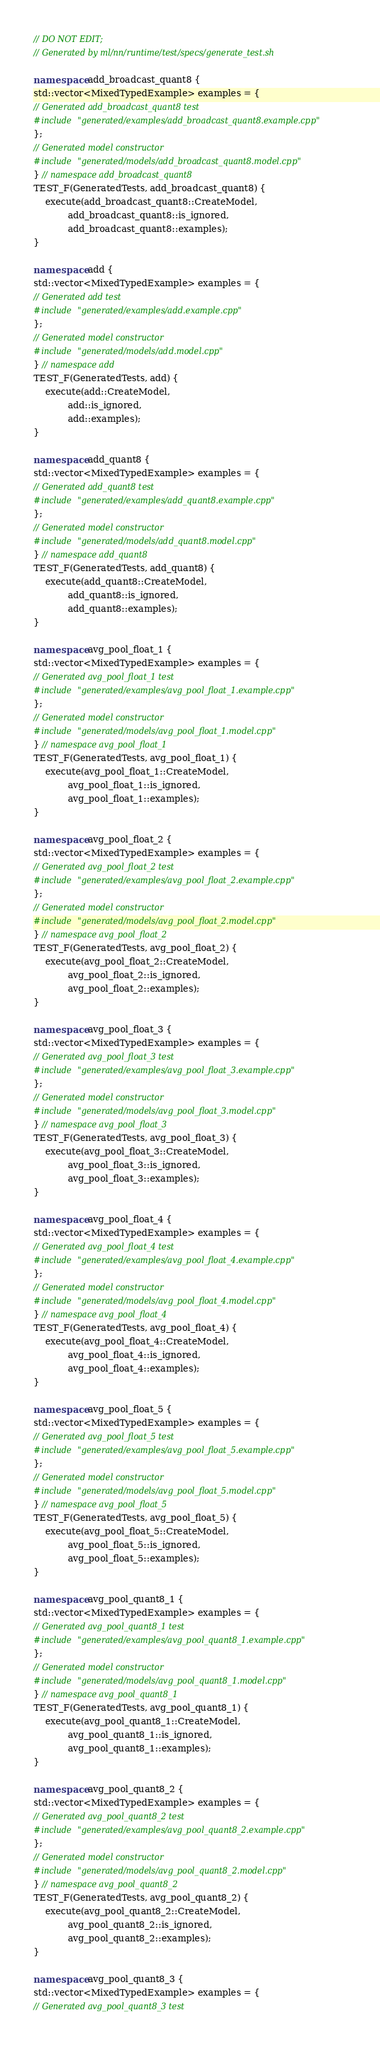<code> <loc_0><loc_0><loc_500><loc_500><_C++_>// DO NOT EDIT;
// Generated by ml/nn/runtime/test/specs/generate_test.sh

namespace add_broadcast_quant8 {
std::vector<MixedTypedExample> examples = {
// Generated add_broadcast_quant8 test
#include "generated/examples/add_broadcast_quant8.example.cpp"
};
// Generated model constructor
#include "generated/models/add_broadcast_quant8.model.cpp"
} // namespace add_broadcast_quant8
TEST_F(GeneratedTests, add_broadcast_quant8) {
    execute(add_broadcast_quant8::CreateModel,
            add_broadcast_quant8::is_ignored,
            add_broadcast_quant8::examples);
}

namespace add {
std::vector<MixedTypedExample> examples = {
// Generated add test
#include "generated/examples/add.example.cpp"
};
// Generated model constructor
#include "generated/models/add.model.cpp"
} // namespace add
TEST_F(GeneratedTests, add) {
    execute(add::CreateModel,
            add::is_ignored,
            add::examples);
}

namespace add_quant8 {
std::vector<MixedTypedExample> examples = {
// Generated add_quant8 test
#include "generated/examples/add_quant8.example.cpp"
};
// Generated model constructor
#include "generated/models/add_quant8.model.cpp"
} // namespace add_quant8
TEST_F(GeneratedTests, add_quant8) {
    execute(add_quant8::CreateModel,
            add_quant8::is_ignored,
            add_quant8::examples);
}

namespace avg_pool_float_1 {
std::vector<MixedTypedExample> examples = {
// Generated avg_pool_float_1 test
#include "generated/examples/avg_pool_float_1.example.cpp"
};
// Generated model constructor
#include "generated/models/avg_pool_float_1.model.cpp"
} // namespace avg_pool_float_1
TEST_F(GeneratedTests, avg_pool_float_1) {
    execute(avg_pool_float_1::CreateModel,
            avg_pool_float_1::is_ignored,
            avg_pool_float_1::examples);
}

namespace avg_pool_float_2 {
std::vector<MixedTypedExample> examples = {
// Generated avg_pool_float_2 test
#include "generated/examples/avg_pool_float_2.example.cpp"
};
// Generated model constructor
#include "generated/models/avg_pool_float_2.model.cpp"
} // namespace avg_pool_float_2
TEST_F(GeneratedTests, avg_pool_float_2) {
    execute(avg_pool_float_2::CreateModel,
            avg_pool_float_2::is_ignored,
            avg_pool_float_2::examples);
}

namespace avg_pool_float_3 {
std::vector<MixedTypedExample> examples = {
// Generated avg_pool_float_3 test
#include "generated/examples/avg_pool_float_3.example.cpp"
};
// Generated model constructor
#include "generated/models/avg_pool_float_3.model.cpp"
} // namespace avg_pool_float_3
TEST_F(GeneratedTests, avg_pool_float_3) {
    execute(avg_pool_float_3::CreateModel,
            avg_pool_float_3::is_ignored,
            avg_pool_float_3::examples);
}

namespace avg_pool_float_4 {
std::vector<MixedTypedExample> examples = {
// Generated avg_pool_float_4 test
#include "generated/examples/avg_pool_float_4.example.cpp"
};
// Generated model constructor
#include "generated/models/avg_pool_float_4.model.cpp"
} // namespace avg_pool_float_4
TEST_F(GeneratedTests, avg_pool_float_4) {
    execute(avg_pool_float_4::CreateModel,
            avg_pool_float_4::is_ignored,
            avg_pool_float_4::examples);
}

namespace avg_pool_float_5 {
std::vector<MixedTypedExample> examples = {
// Generated avg_pool_float_5 test
#include "generated/examples/avg_pool_float_5.example.cpp"
};
// Generated model constructor
#include "generated/models/avg_pool_float_5.model.cpp"
} // namespace avg_pool_float_5
TEST_F(GeneratedTests, avg_pool_float_5) {
    execute(avg_pool_float_5::CreateModel,
            avg_pool_float_5::is_ignored,
            avg_pool_float_5::examples);
}

namespace avg_pool_quant8_1 {
std::vector<MixedTypedExample> examples = {
// Generated avg_pool_quant8_1 test
#include "generated/examples/avg_pool_quant8_1.example.cpp"
};
// Generated model constructor
#include "generated/models/avg_pool_quant8_1.model.cpp"
} // namespace avg_pool_quant8_1
TEST_F(GeneratedTests, avg_pool_quant8_1) {
    execute(avg_pool_quant8_1::CreateModel,
            avg_pool_quant8_1::is_ignored,
            avg_pool_quant8_1::examples);
}

namespace avg_pool_quant8_2 {
std::vector<MixedTypedExample> examples = {
// Generated avg_pool_quant8_2 test
#include "generated/examples/avg_pool_quant8_2.example.cpp"
};
// Generated model constructor
#include "generated/models/avg_pool_quant8_2.model.cpp"
} // namespace avg_pool_quant8_2
TEST_F(GeneratedTests, avg_pool_quant8_2) {
    execute(avg_pool_quant8_2::CreateModel,
            avg_pool_quant8_2::is_ignored,
            avg_pool_quant8_2::examples);
}

namespace avg_pool_quant8_3 {
std::vector<MixedTypedExample> examples = {
// Generated avg_pool_quant8_3 test</code> 